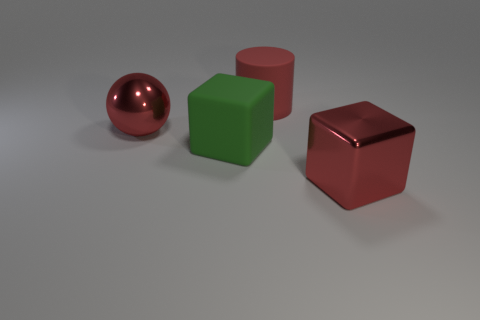There is a shiny thing that is the same shape as the big green matte object; what color is it?
Your response must be concise. Red. There is a metallic object behind the red shiny cube; is its color the same as the large matte thing in front of the big sphere?
Your answer should be compact. No. Is the number of red matte things behind the red rubber cylinder greater than the number of big cyan metallic spheres?
Provide a short and direct response. No. How many other objects are there of the same size as the metallic cube?
Provide a short and direct response. 3. What number of large red objects are both behind the green rubber thing and right of the large green rubber block?
Offer a terse response. 1. Is the material of the red thing that is behind the large red ball the same as the green block?
Offer a very short reply. Yes. The big red shiny object behind the large red shiny thing to the right of the red metallic thing that is left of the large metallic block is what shape?
Your answer should be compact. Sphere. Are there the same number of matte objects in front of the large red sphere and large cubes that are behind the large matte cube?
Your answer should be compact. No. There is a matte block that is the same size as the red matte object; what is its color?
Your answer should be compact. Green. What number of large objects are purple rubber things or metal cubes?
Keep it short and to the point. 1. 